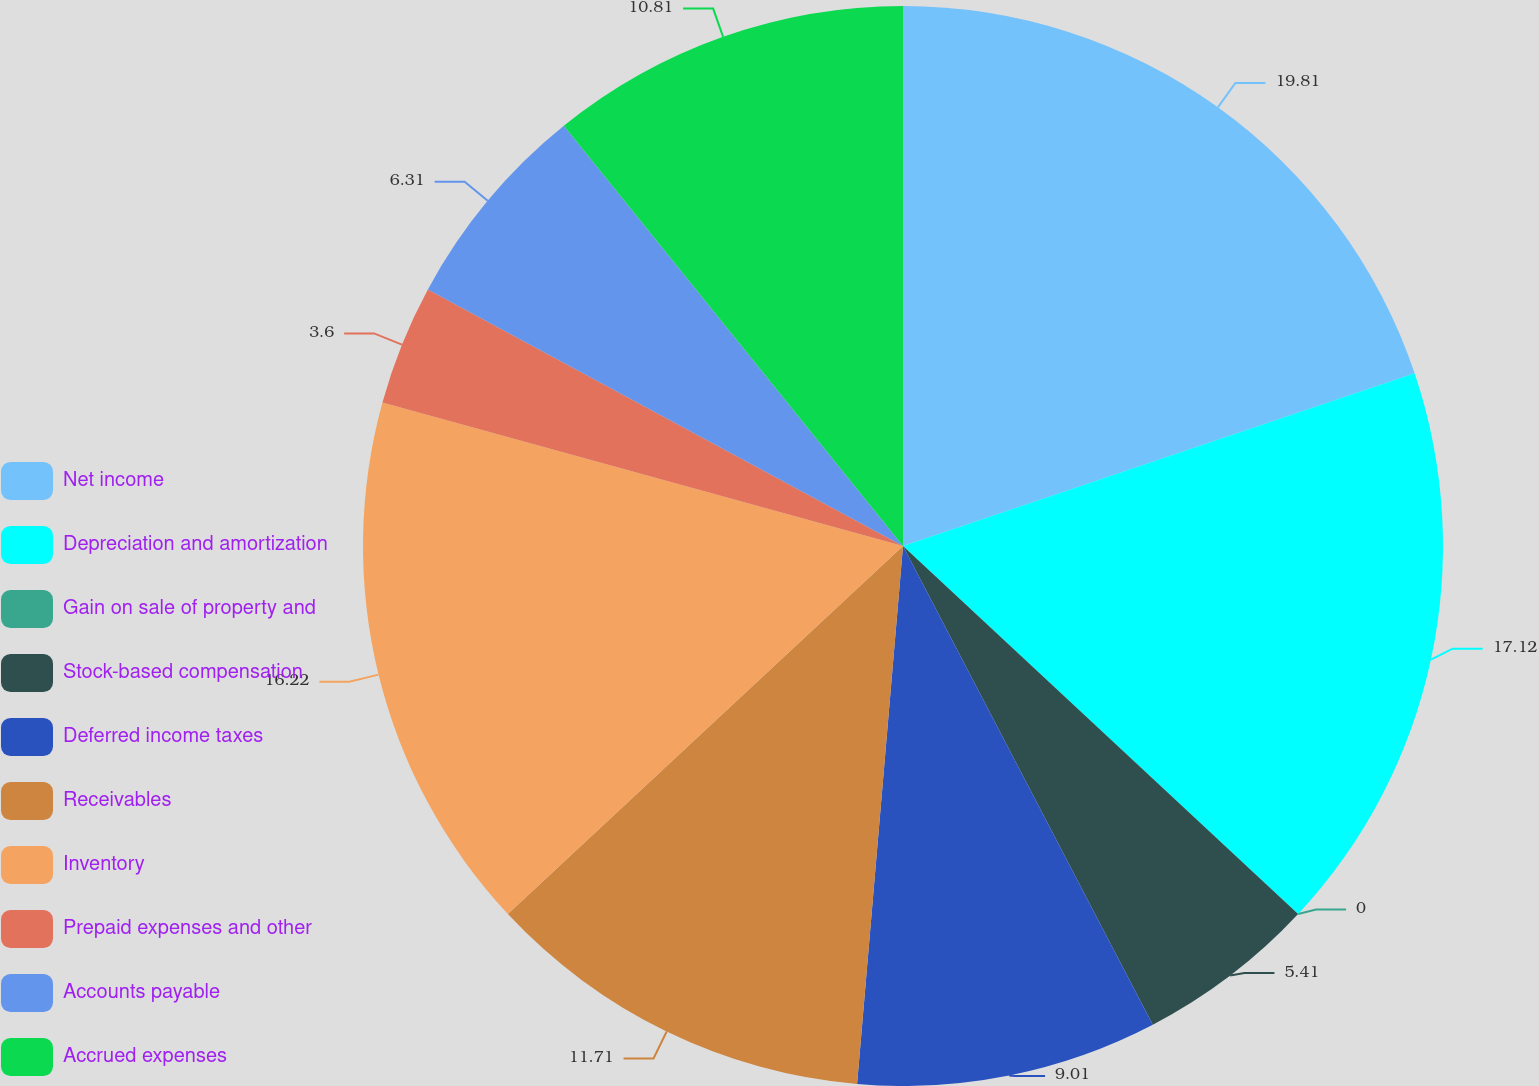Convert chart to OTSL. <chart><loc_0><loc_0><loc_500><loc_500><pie_chart><fcel>Net income<fcel>Depreciation and amortization<fcel>Gain on sale of property and<fcel>Stock-based compensation<fcel>Deferred income taxes<fcel>Receivables<fcel>Inventory<fcel>Prepaid expenses and other<fcel>Accounts payable<fcel>Accrued expenses<nl><fcel>19.82%<fcel>17.12%<fcel>0.0%<fcel>5.41%<fcel>9.01%<fcel>11.71%<fcel>16.22%<fcel>3.6%<fcel>6.31%<fcel>10.81%<nl></chart> 